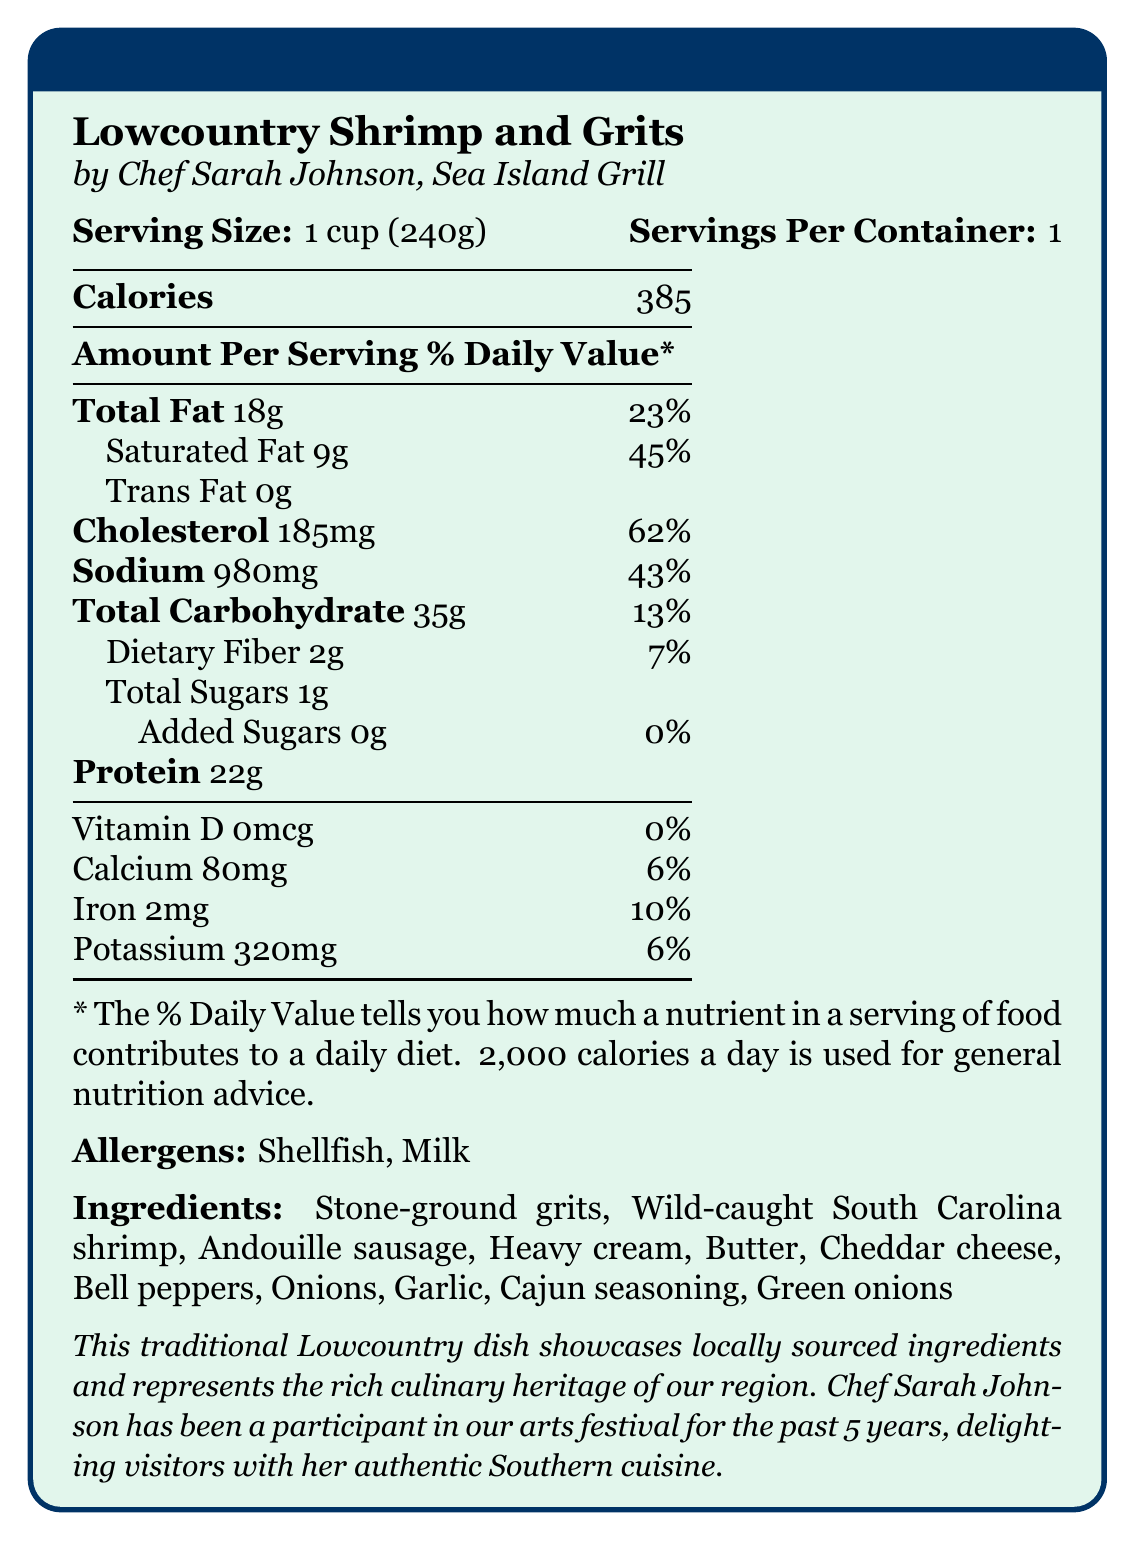what is the serving size for Lowcountry Shrimp and Grits? The document states that the serving size is 1 cup (240g).
Answer: 1 cup (240g) who is the chef that prepared the Lowcountry Shrimp and Grits? The document mentions that Chef Sarah Johnson is the one who prepared the dish.
Answer: Chef Sarah Johnson how much saturated fat is in a serving of Lowcountry Shrimp and Grits? The nutrition facts indicate that there are 9 grams of saturated fat per serving.
Answer: 9 grams what allergens are present in Lowcountry Shrimp and Grits? The document lists Shellfish and Milk as allergens present in the dish.
Answer: Shellfish, Milk how many calories are in one serving of Lowcountry Shrimp and Grits? The document states that there are 385 calories per serving.
Answer: 385 how much cholesterol is in a serving of Lowcountry Shrimp and Grits? The document specifies that there are 185 milligrams of cholesterol per serving.
Answer: 185 mg what is the source of the shrimp used in this dish? A. Farm-raised shrimp B. Imported shrimp C. Wild-caught South Carolina shrimp D. Freshwater shrimp The document mentions that wild-caught South Carolina shrimp are used in the recipe.
Answer: C how many grams of dietary fiber are in a serving of Lowcountry Shrimp and Grits? The nutrition facts state that there are 2 grams of dietary fiber per serving.
Answer: 2 grams how many total carbohydrates does Lowcountry Shrimp and Grits contain? The nutrition label shows that the dish contains 35 grams of total carbohydrates.
Answer: 35 grams what vitamins or minerals have a daily value percentage of more than 10%? The items with a daily value of over 10% are Cholesterol (62%), Sodium (43%), and Saturated Fat (45%).
Answer: Cholesterol, Sodium, Saturated Fat which of the following ingredients is not listed in the Lowcountry Shrimp and Grits recipe? A. Andouille sausage B. Bell peppers C. Tomatoes D. Green onions The document does not list tomatoes as an ingredient.
Answer: C is there any added sugar in this dish? The document states there are 0 grams of added sugars.
Answer: No what is the protein content in a cup of Lowcountry Shrimp and Grits? The nutrition facts show that there are 22 grams of protein per serving.
Answer: 22 grams can we determine the cost of preparation for this dish from the document? The document does not provide any information regarding the cost of preparation.
Answer: Cannot be determined summarize the main details provided in the document. The summary includes all the primary information such as the nutrition breakdown, chef and restaurant details, main ingredients, allergens, and the context of the arts festival.
Answer: The document provides the nutrition facts for Lowcountry Shrimp and Grits made by Chef Sarah Johnson from Sea Island Grill. It details the serving size, calorie content, amounts of various nutrients, allergens, and ingredients. It also notes that this dish is part of a local arts festival celebrating regional culinary heritage using locally sourced ingredients. Additionally, Chef Sarah Johnson is highlighted as a long-time participant in the festival. 